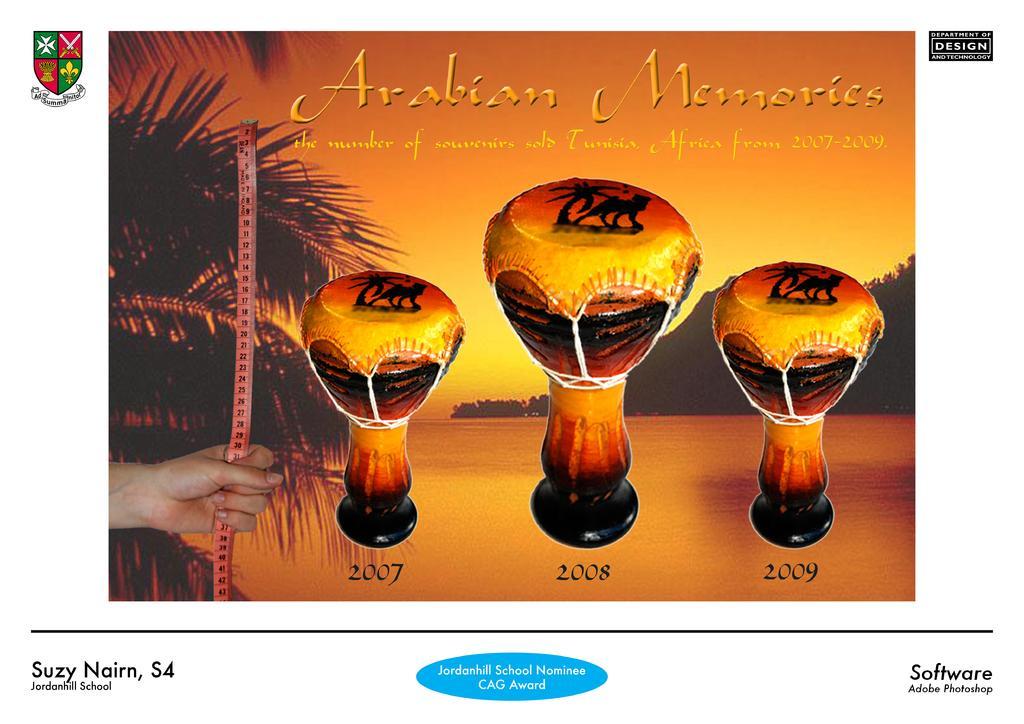Could you give a brief overview of what you see in this image? On the left of this picture we can see the hand of a person holding a ruler. In the background we can see the banner on which we can see the picture of a sky, trees and some wooden objects and we can see the picture of some animals and there is a text on the image and the logo on the image. 